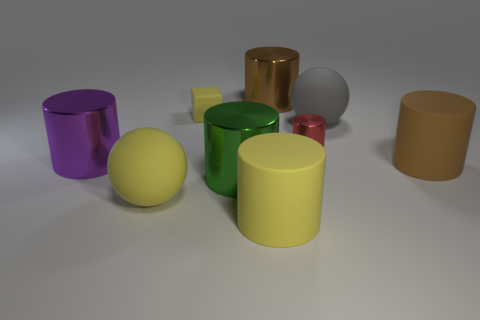Are there any patterns or designs on the objects? The objects do not display any discernible patterns or intricate designs. Their surfaces are uniformly colored, presenting solid hues. This simplicity allows for a clear and unobstructed observation of color and light interactions, as well as the study of geometric shapes and reflections. 